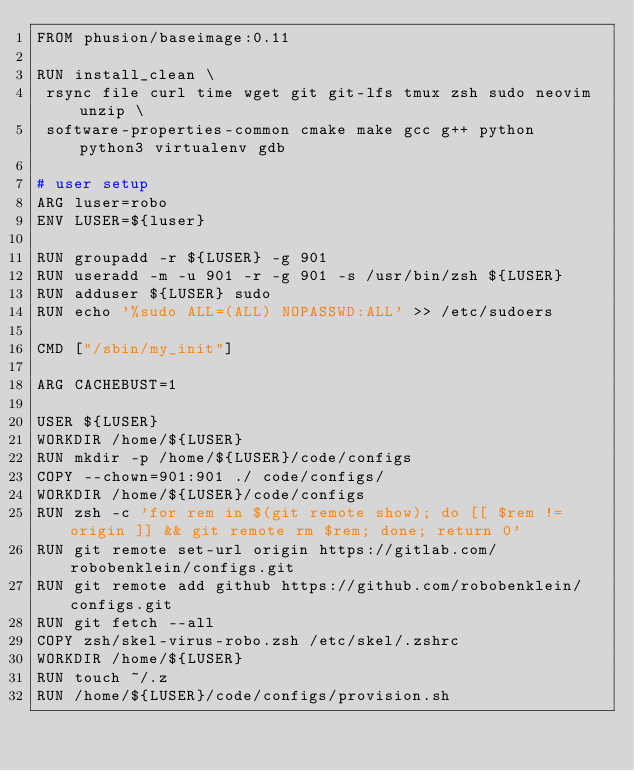Convert code to text. <code><loc_0><loc_0><loc_500><loc_500><_Dockerfile_>FROM phusion/baseimage:0.11

RUN install_clean \
 rsync file curl time wget git git-lfs tmux zsh sudo neovim unzip \
 software-properties-common cmake make gcc g++ python python3 virtualenv gdb

# user setup
ARG luser=robo
ENV LUSER=${luser}

RUN groupadd -r ${LUSER} -g 901
RUN useradd -m -u 901 -r -g 901 -s /usr/bin/zsh ${LUSER}
RUN adduser ${LUSER} sudo
RUN echo '%sudo ALL=(ALL) NOPASSWD:ALL' >> /etc/sudoers

CMD ["/sbin/my_init"]

ARG CACHEBUST=1

USER ${LUSER}
WORKDIR /home/${LUSER}
RUN mkdir -p /home/${LUSER}/code/configs
COPY --chown=901:901 ./ code/configs/
WORKDIR /home/${LUSER}/code/configs
RUN zsh -c 'for rem in $(git remote show); do [[ $rem != origin ]] && git remote rm $rem; done; return 0'
RUN git remote set-url origin https://gitlab.com/robobenklein/configs.git
RUN git remote add github https://github.com/robobenklein/configs.git
RUN git fetch --all
COPY zsh/skel-virus-robo.zsh /etc/skel/.zshrc
WORKDIR /home/${LUSER}
RUN touch ~/.z
RUN /home/${LUSER}/code/configs/provision.sh
</code> 